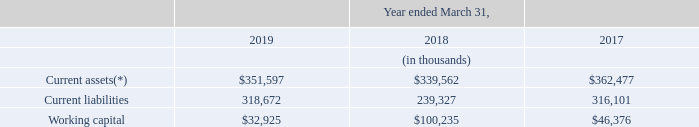B. Liquidity and Capital Resources
Our operations and strategic objectives require continuing capital investment, and our resources include cash on hand and cash provided by operations, as well as access to capital from bank borrowings and access to capital markets. Management believes that cash generated by or available to us should be sufficient to fund our capital and liquidity needs for at least the next 12 months.
Our future financial and operating performance, ability to service or refinance debt and ability to comply with covenants and restrictions contained in our debt agreements will be subject to future economic conditions, the financial health of our customers and suppliers and to financial, business and other factors, many of which are beyond our control. Furthermore, management believes that working capital is sufficient for our present requirements.
(*) including trade receivables classified as current asset based on operating cycle of two years.
The decrease in working capital as at March 31, 2019 as compared to March 31, 2018 was primarily the result of an increase in short-term borrowings amounting to $208.9 million as at March 31, 2019 from $152 million as at March 31, 2018 due to overdraft against restricted deposits and loan installments due within 12 months.
For additional information, please see Note 2(a) and Note 32 to our audited Consolidated Financial Statements appearing elsewhere in this annual report.
What caused the decrease in working capital in 2019? Primarily the result of an increase in short-term borrowings amounting to $208.9 million as at march 31, 2019 from $152 million as at march 31, 2018 due to overdraft against restricted deposits and loan installments due within 12 months. What was the Working capital in 2019?
Answer scale should be: thousand. $32,925. What years are included in the table? 2019, 2018, 2017. What is the increase / (decrease) in the current assets from 2018 to 2019?
Answer scale should be: thousand. 351,597 - 339,562
Answer: 12035. What is the average current liabilities from 2017-2019?
Answer scale should be: thousand. (318,672 + 239,327 + 316,101) / 3
Answer: 291366.67. What is the increase / (decrease) in the working capital from 2018 to 2019?
Answer scale should be: thousand. 32,925 - 100,235
Answer: -67310. 